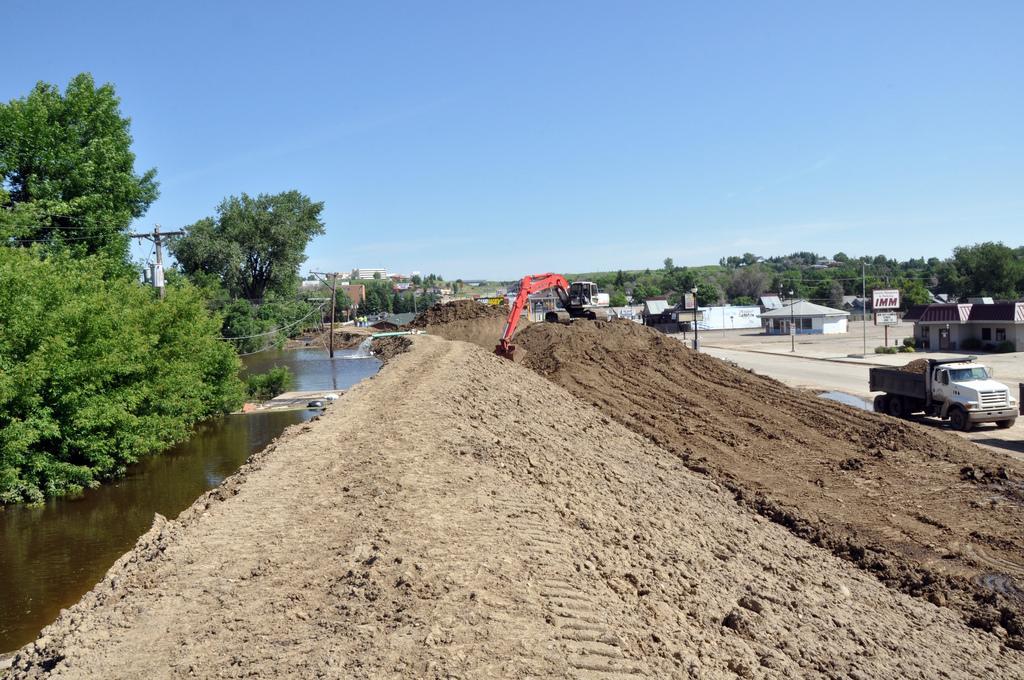Can you describe this image briefly? This is the outside view of city. There is a vehicle on the road. We can observe small houses on the left side of the picture. Even we can observe an excavator hire. And on the background there is a sky, and even we can observe trees on the right side of the picture. And there is water and this is the pole. 